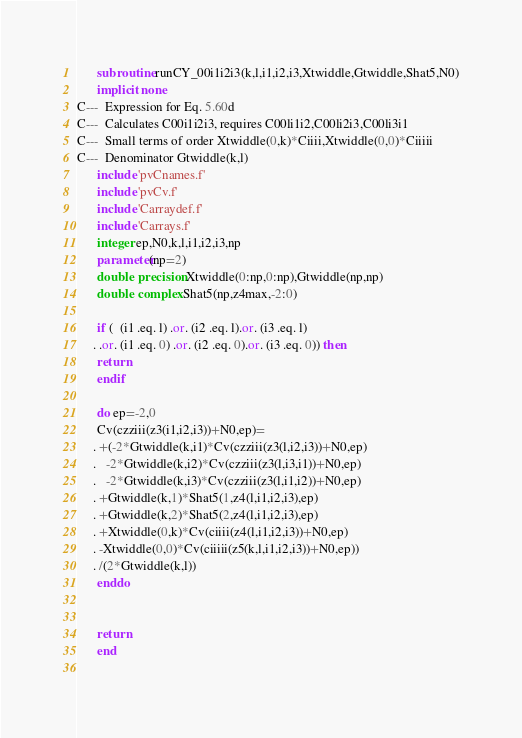<code> <loc_0><loc_0><loc_500><loc_500><_FORTRAN_>      subroutine runCY_00i1i2i3(k,l,i1,i2,i3,Xtwiddle,Gtwiddle,Shat5,N0)
      implicit none
C---  Expression for Eq. 5.60d
C---  Calculates C00i1i2i3, requires C00li1i2,C00li2i3,C00li3i1
C---  Small terms of order Xtwiddle(0,k)*Ciiii,Xtwiddle(0,0)*Ciiiii
C---  Denominator Gtwiddle(k,l)
      include 'pvCnames.f' 
      include 'pvCv.f' 
      include 'Carraydef.f' 
      include 'Carrays.f' 
      integer ep,N0,k,l,i1,i2,i3,np
      parameter(np=2)
      double precision Xtwiddle(0:np,0:np),Gtwiddle(np,np)
      double complex Shat5(np,z4max,-2:0)

      if (  (i1 .eq. l) .or. (i2 .eq. l).or. (i3 .eq. l)
     . .or. (i1 .eq. 0) .or. (i2 .eq. 0).or. (i3 .eq. 0)) then
      return
      endif

      do ep=-2,0
      Cv(czziii(z3(i1,i2,i3))+N0,ep)=
     . +(-2*Gtwiddle(k,i1)*Cv(czziii(z3(l,i2,i3))+N0,ep)
     .   -2*Gtwiddle(k,i2)*Cv(czziii(z3(l,i3,i1))+N0,ep)
     .   -2*Gtwiddle(k,i3)*Cv(czziii(z3(l,i1,i2))+N0,ep)
     . +Gtwiddle(k,1)*Shat5(1,z4(l,i1,i2,i3),ep)
     . +Gtwiddle(k,2)*Shat5(2,z4(l,i1,i2,i3),ep)
     . +Xtwiddle(0,k)*Cv(ciiii(z4(l,i1,i2,i3))+N0,ep)
     . -Xtwiddle(0,0)*Cv(ciiiii(z5(k,l,i1,i2,i3))+N0,ep))
     . /(2*Gtwiddle(k,l))
      enddo


      return
      end
  



</code> 